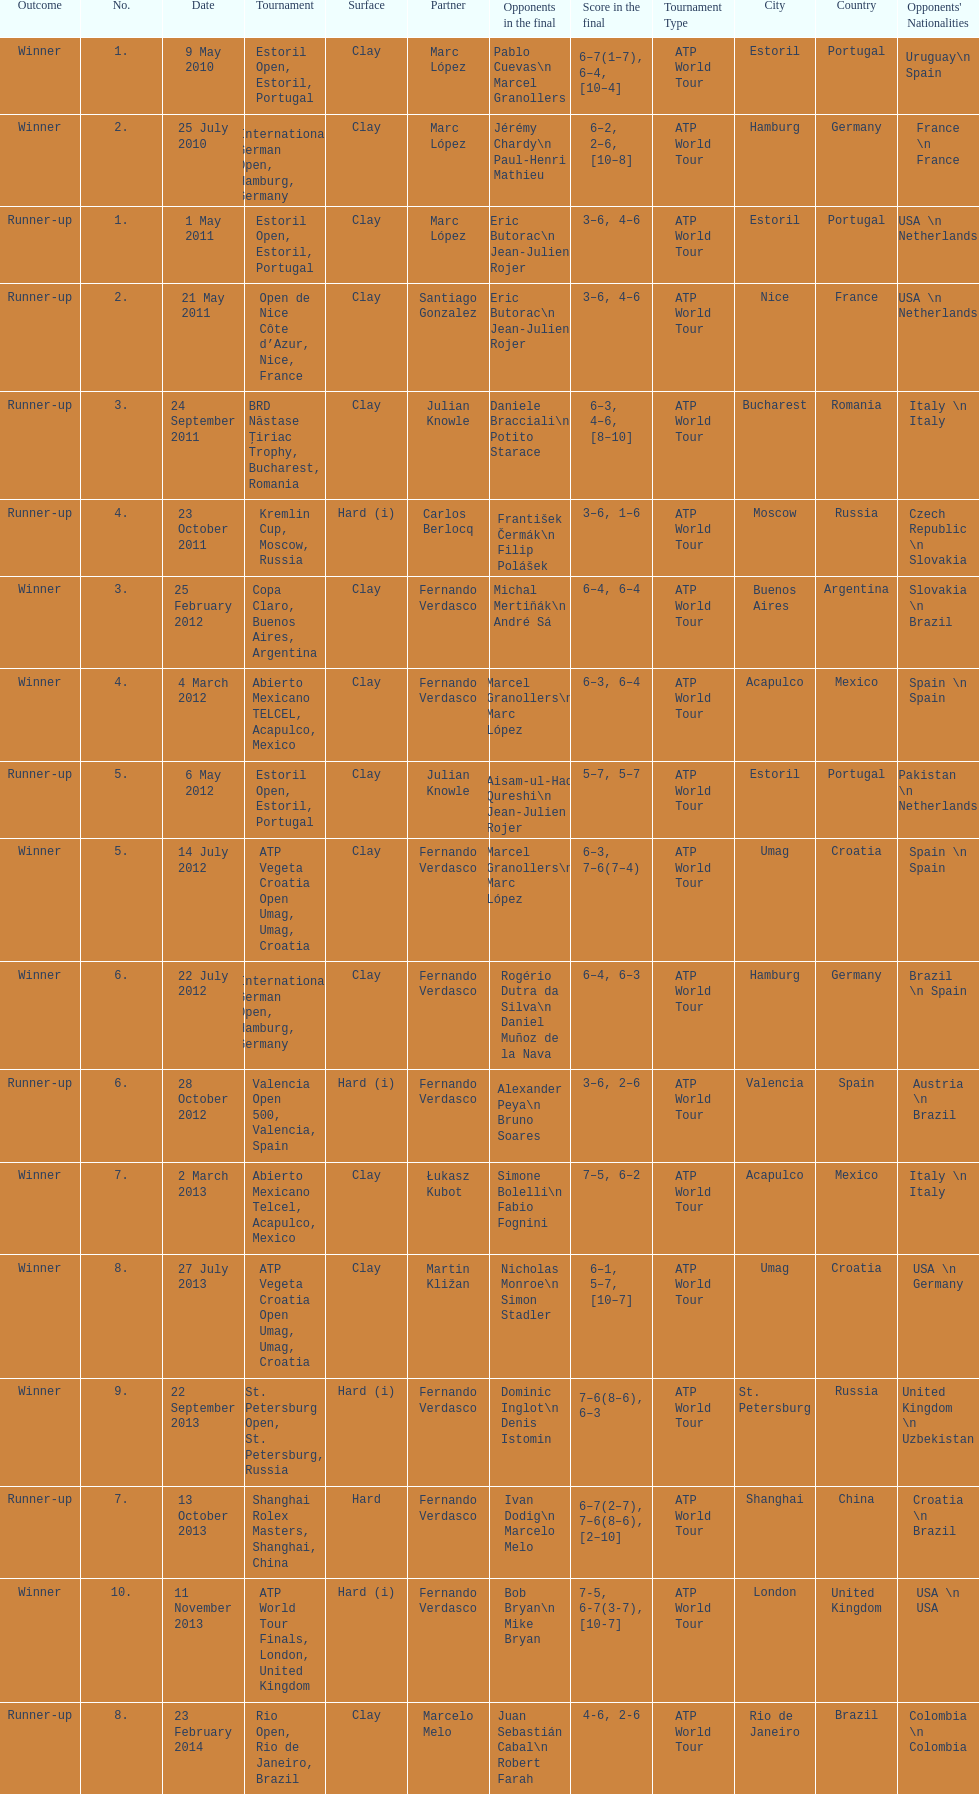How many runner-ups at most are listed? 8. 